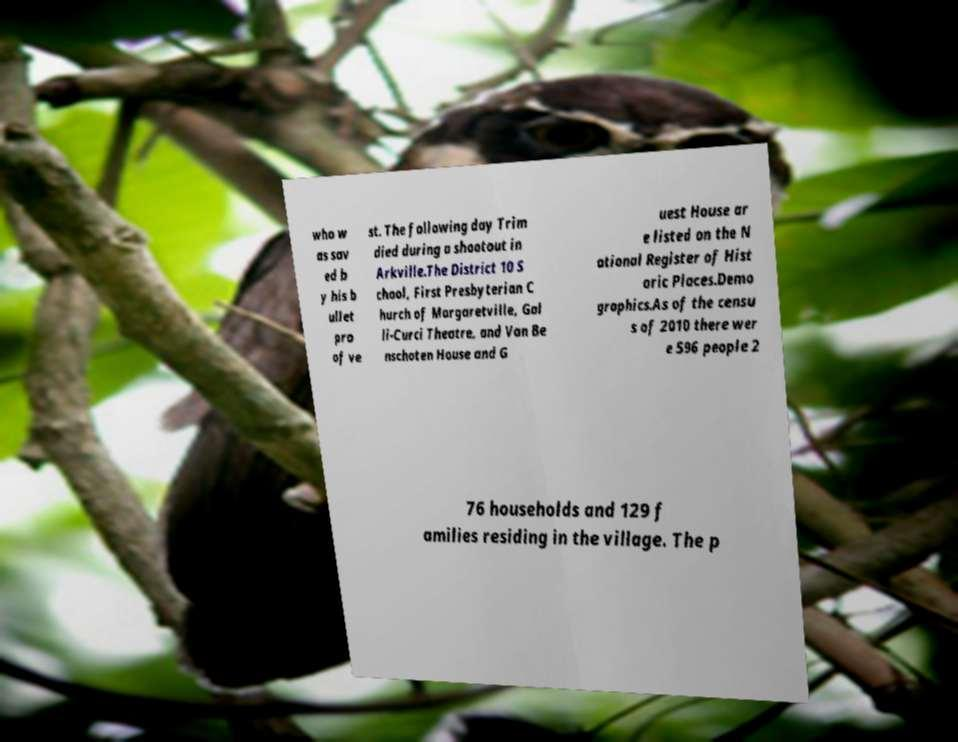There's text embedded in this image that I need extracted. Can you transcribe it verbatim? who w as sav ed b y his b ullet pro of ve st. The following day Trim died during a shootout in Arkville.The District 10 S chool, First Presbyterian C hurch of Margaretville, Gal li-Curci Theatre, and Van Be nschoten House and G uest House ar e listed on the N ational Register of Hist oric Places.Demo graphics.As of the censu s of 2010 there wer e 596 people 2 76 households and 129 f amilies residing in the village. The p 